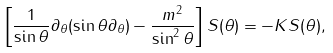<formula> <loc_0><loc_0><loc_500><loc_500>\left [ \frac { 1 } { \sin \theta } \partial _ { \theta } ( \sin \theta \partial _ { \theta } ) - \frac { m ^ { 2 } } { \sin ^ { 2 } \theta } \right ] S ( \theta ) = - K S ( \theta ) ,</formula> 